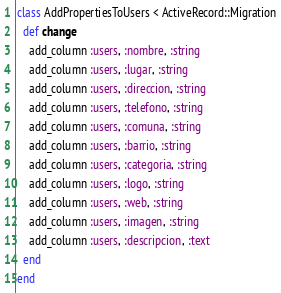Convert code to text. <code><loc_0><loc_0><loc_500><loc_500><_Ruby_>class AddPropertiesToUsers < ActiveRecord::Migration
  def change
    add_column :users, :nombre, :string
    add_column :users, :lugar, :string
    add_column :users, :direccion, :string
    add_column :users, :telefono, :string
    add_column :users, :comuna, :string
    add_column :users, :barrio, :string
    add_column :users, :categoria, :string
    add_column :users, :logo, :string
    add_column :users, :web, :string
    add_column :users, :imagen, :string
    add_column :users, :descripcion, :text
  end
end
</code> 